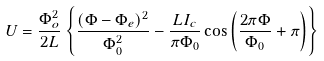Convert formula to latex. <formula><loc_0><loc_0><loc_500><loc_500>U = \frac { \Phi _ { o } ^ { 2 } } { 2 L } \left \{ \frac { ( \Phi - \Phi _ { e } ) ^ { 2 } } { \Phi _ { 0 } ^ { 2 } } - \frac { L I _ { c } } { \pi \Phi _ { 0 } } \cos \left ( \frac { 2 \pi \Phi } { \Phi _ { 0 } } + \pi \right ) \right \}</formula> 